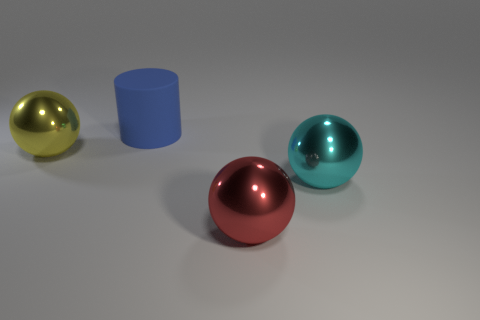Is there a rubber sphere that has the same color as the big cylinder?
Provide a succinct answer. No. There is a cylinder that is the same size as the yellow thing; what is its color?
Your answer should be compact. Blue. Does the red object have the same shape as the big blue thing?
Ensure brevity in your answer.  No. What material is the large ball that is to the left of the blue rubber cylinder?
Make the answer very short. Metal. The rubber cylinder is what color?
Make the answer very short. Blue. Is the size of the metallic object that is in front of the cyan shiny object the same as the metallic ball left of the blue thing?
Make the answer very short. Yes. How big is the sphere that is left of the big cyan shiny thing and on the right side of the yellow metal sphere?
Give a very brief answer. Large. Are there more yellow metallic objects to the right of the yellow shiny object than red things behind the red metal object?
Offer a very short reply. No. How many other objects are the same shape as the yellow shiny thing?
Your response must be concise. 2. Are there any big blue matte cylinders to the left of the object behind the yellow thing?
Make the answer very short. No. 